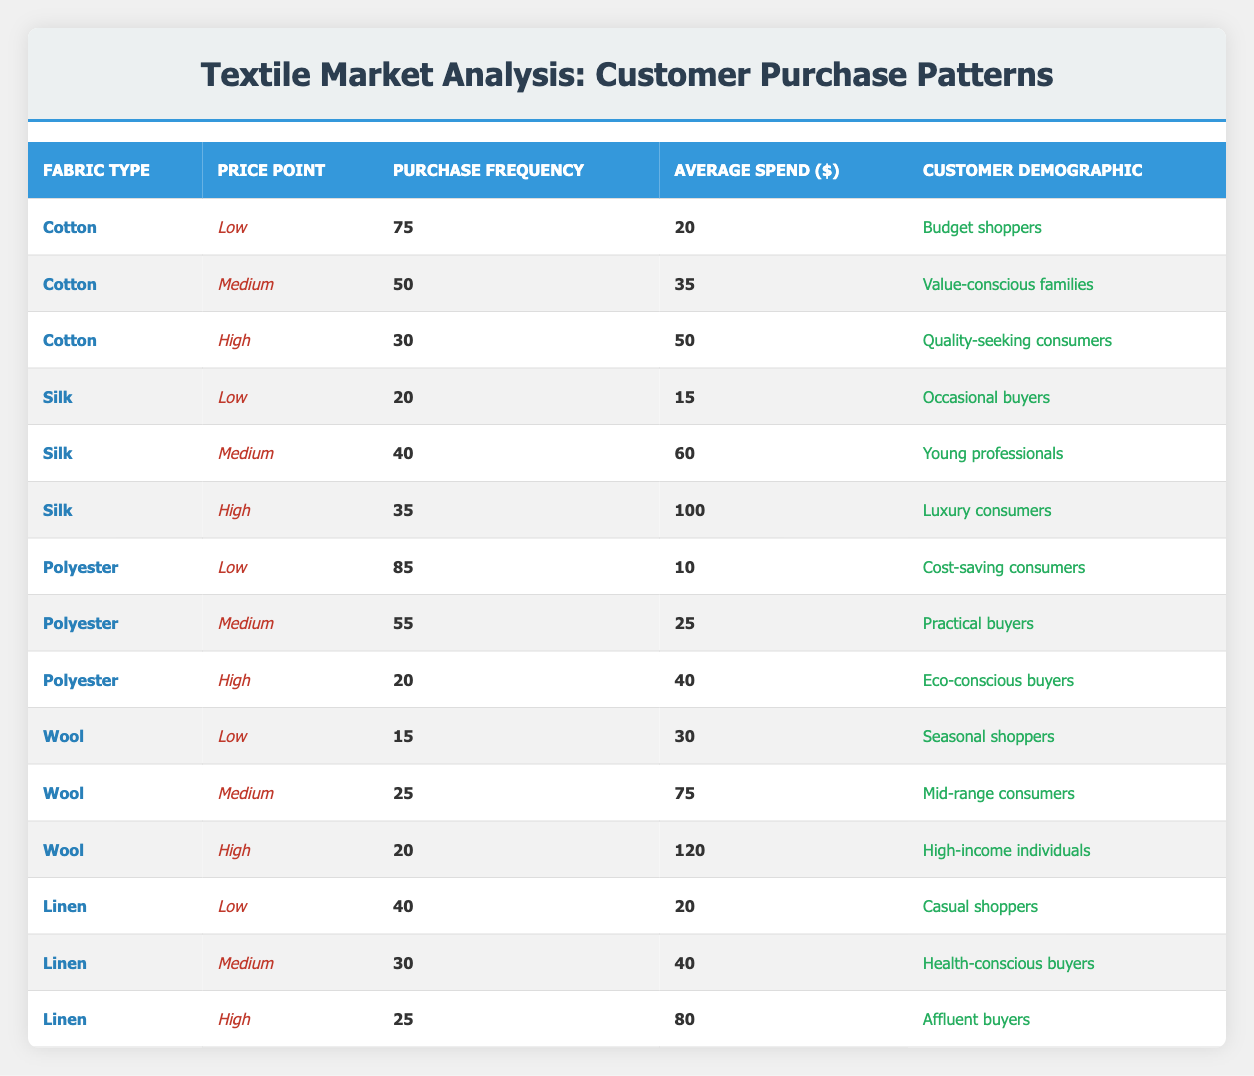What is the purchase frequency for cotton at the low price point? The table shows that the purchase frequency for cotton at the low price point is listed in the row corresponding to cotton and low price point. It is noted as 75.
Answer: 75 What is the average spend of polyester for medium price point? The average spend for polyester at the medium price point can be found in the polyester row under the medium price point column. It states that average spend is 25.
Answer: 25 How many customers purchase silk at the high price point compared to cotton at the high price point? The table indicates that the purchase frequency for silk at the high price point is 35 and for cotton at the high price point it is 30. So, comparing these shows that silk has more purchases than cotton by 5.
Answer: Silk has 5 more customers Is it true that budget shoppers prefer low-priced cotton over high-priced silk? The table indicates that budget shoppers purchase cotton at the low price point with a frequency of 75, while high-priced silk has a purchase frequency of 35. Since 75 is greater than 35, the statement is true.
Answer: True What is the average spend of all fabric types at the medium price point? To find the average spend at the medium price point, we sum the average spends for medium price points across all fabric types: (35 + 60 + 25 + 75 + 40) = 235. There are 5 medium price points, so the average is calculated as 235/5 = 47.
Answer: 47 Which fabric type has the highest purchase frequency at the low price point? The data shows that polyester has a purchase frequency of 85 at the low price point, which is higher than any other fabric type's purchase frequency at the same price point, making it the highest.
Answer: Polyester What is the difference in average spend between high-priced wool and low-priced linen? The average spend for high-priced wool is 120 and for low-priced linen, it is 20. To find the difference, we calculate 120 - 20 = 100.
Answer: 100 Do young professionals purchase more silk at the medium price point than casual shoppers purchase linen at the low price point? Young professionals buy silk at the medium price point with a purchase frequency of 40, while casual shoppers buy linen at the low price point with a purchase frequency of 40 as well. Therefore, they purchase an equal number, making the statement false.
Answer: False What is the total purchase frequency of all fabric types at the high price point? To determine this, we sum the purchase frequencies at the high price point: (30 + 35 + 20 + 20 + 25) = 130. Therefore, the total purchase frequency is 130.
Answer: 130 